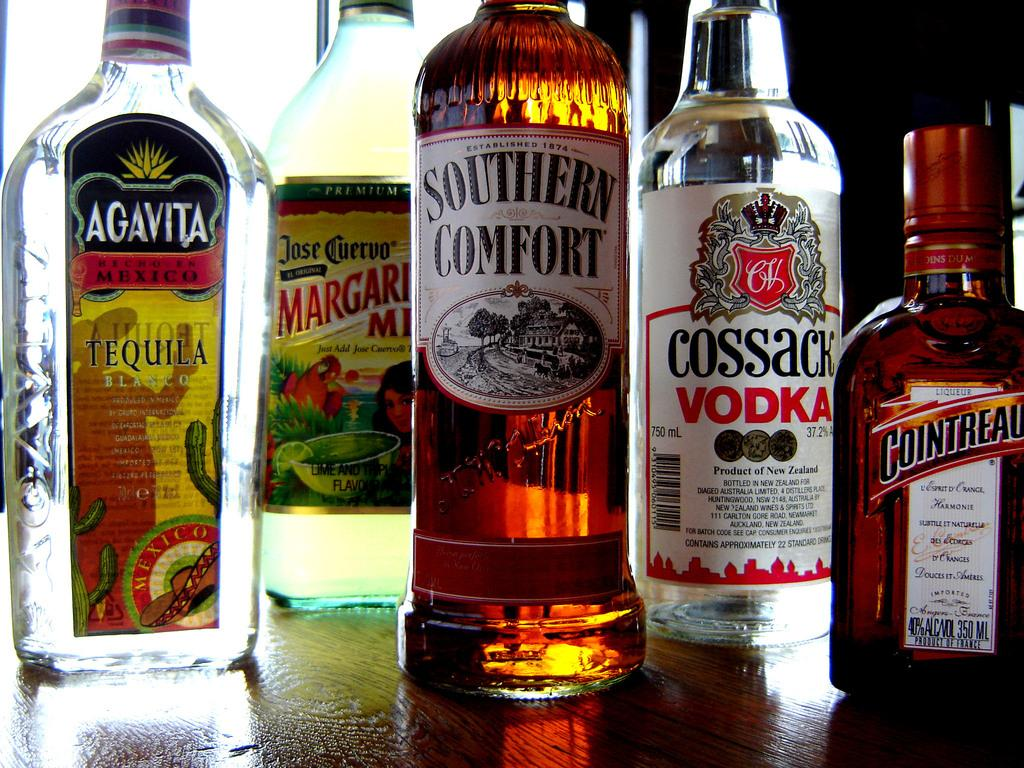Provide a one-sentence caption for the provided image. A bottle of Southern Comfort next to a bottle of Jose Cuervo Margarita mix. 